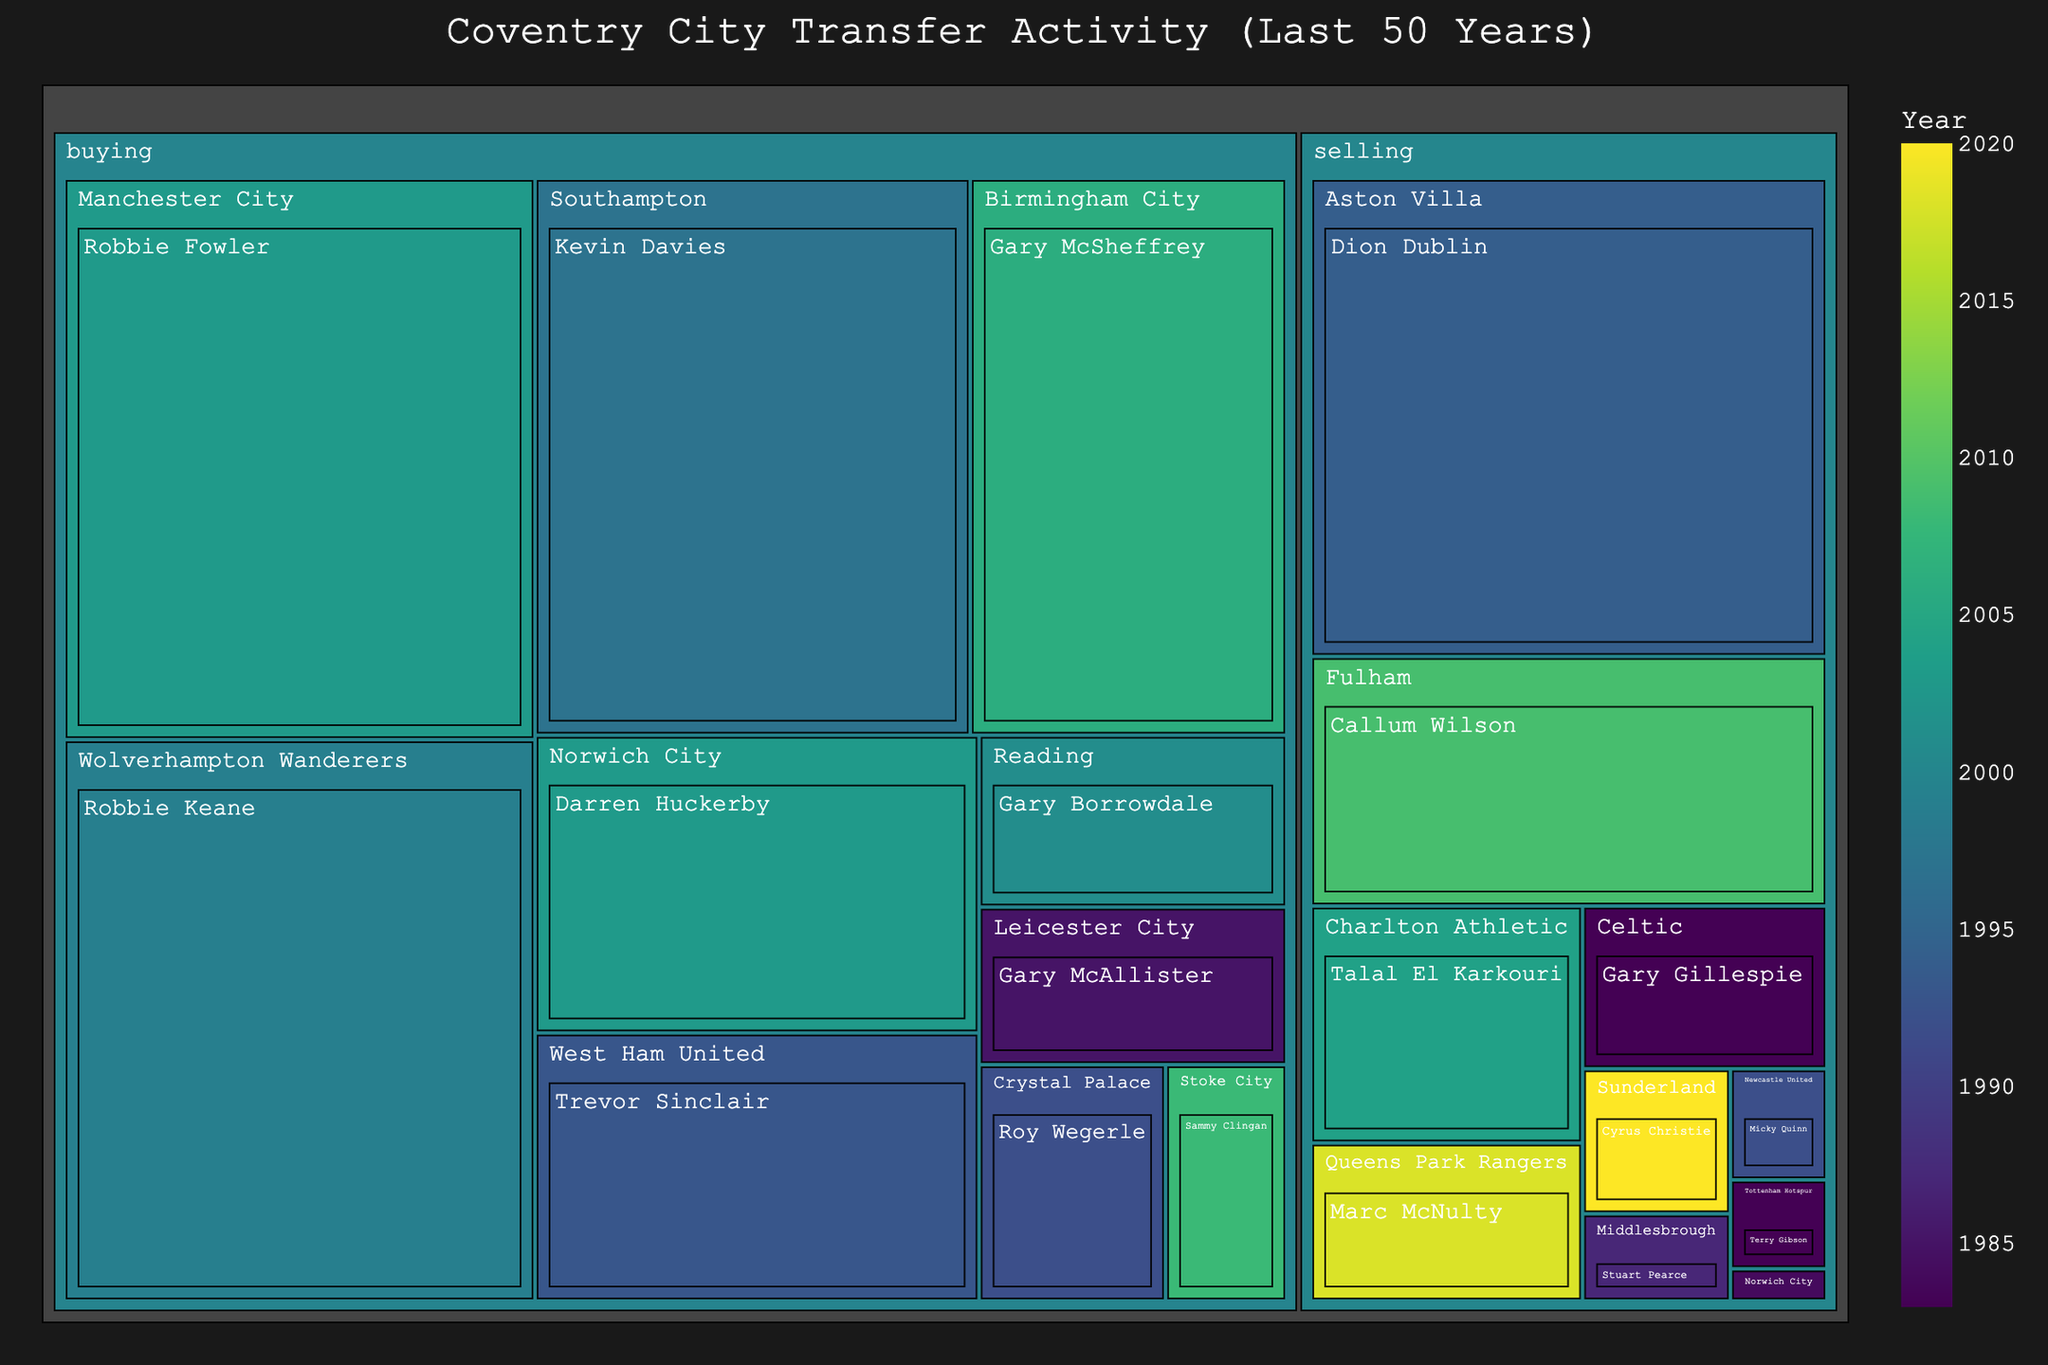What is the title of the figure? The title is shown prominently at the top of the treemap.
Answer: Coventry City Transfer Activity (Last 50 Years) Which club has the highest transfer fee in the selling category? The highest fee in the selling category can be seen in the size of the boxes and the hover data.
Answer: Aston Villa What year did Fulham buy a player from Coventry City? By hovering over Fulham in the treemap or checking the color that corresponds to Fulham, you can find the year in the hover data or color scale.
Answer: 2009 How many players did Norwich City interact with in transfers? Count the number of individual players listed under both buying and selling categories for Norwich City.
Answer: 2 What's the combined transfer fee for selling players to Premier League clubs? Summing the fees of transfers to clubs labeled under selling: Aston Villa (5750000), Tottenham Hotspur (200000), Newcastle United (250000). Sum these values.
Answer: £6,200,000 What is the average transfer fee for the buying category? Sum the fees labeled under buying and divide by the number of data points in the buying category: (6000000 + 6000000 + 5500000 + 3000000 + 1100000 + 1000000 + 2700000 + 4000000 + 650000 + 1200000) / 10.
Answer: £3,270,000 Which transfer had the lowest fee, and what was that fee? Identify the smallest box in the treemap and hover over it to find the fee.
Answer: Steve Ogrizovic (£72,500) What is the difference in transfer fees between Gary McSheffrey and Roy Wegerle? Subtract Roy Wegerle's fee from Gary McSheffrey’s fee (4000000 - 1000000).
Answer: £3,000,000 Among the transfers, which player was involved in the earliest year and what club did they transfer to? Hover over the boxes or refer to the smallest value on the color scale for the year and check the club associated with it.
Answer: Gary Gillespie, Celtic (1983) Which club appears in both buying and selling categories, and how many players are associated with this club? Check for clubs listed under both buying and selling categories and sum the players under each category.
Answer: Norwich City, 2 players 